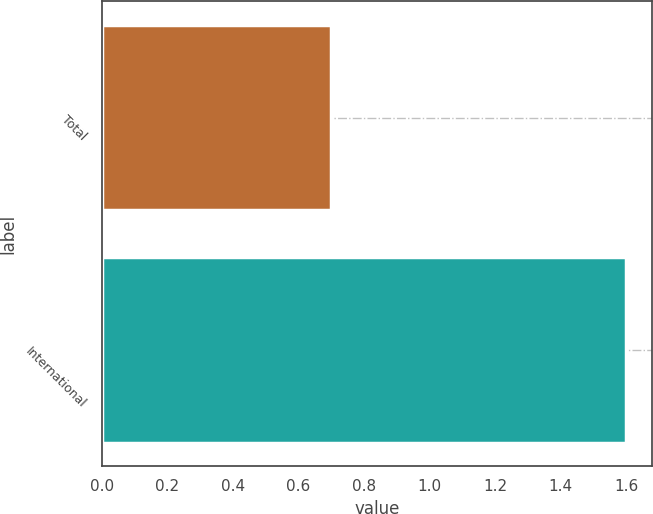Convert chart. <chart><loc_0><loc_0><loc_500><loc_500><bar_chart><fcel>Total<fcel>International<nl><fcel>0.7<fcel>1.6<nl></chart> 